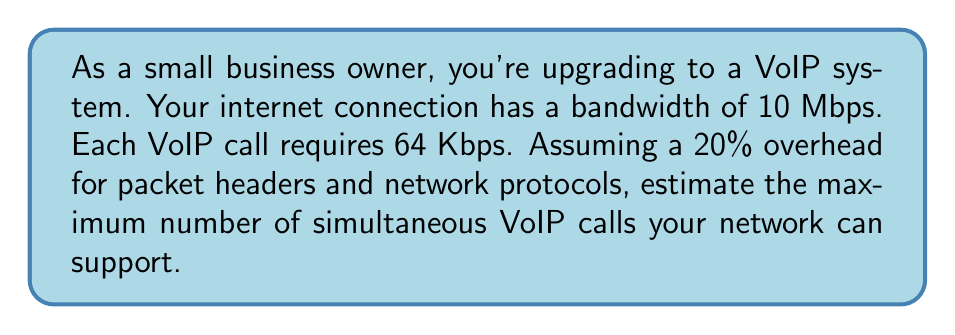Can you solve this math problem? Let's approach this step-by-step:

1) First, we need to convert all units to the same scale. Let's use Kbps:
   10 Mbps = 10,000 Kbps

2) Now, we need to account for the 20% overhead:
   Available bandwidth = 10,000 Kbps × (1 - 0.20) = 8,000 Kbps

3) Each VoIP call requires 64 Kbps. To find the number of calls, we divide the available bandwidth by the bandwidth per call:

   $$\text{Number of calls} = \frac{\text{Available bandwidth}}{\text{Bandwidth per call}}$$

   $$\text{Number of calls} = \frac{8,000 \text{ Kbps}}{64 \text{ Kbps}}$$

4) Performing the division:
   $$\text{Number of calls} = 125$$

5) Since we can't have a fractional call, we round down to the nearest whole number.

Therefore, the network can support a maximum of 125 simultaneous VoIP calls.
Answer: 125 calls 